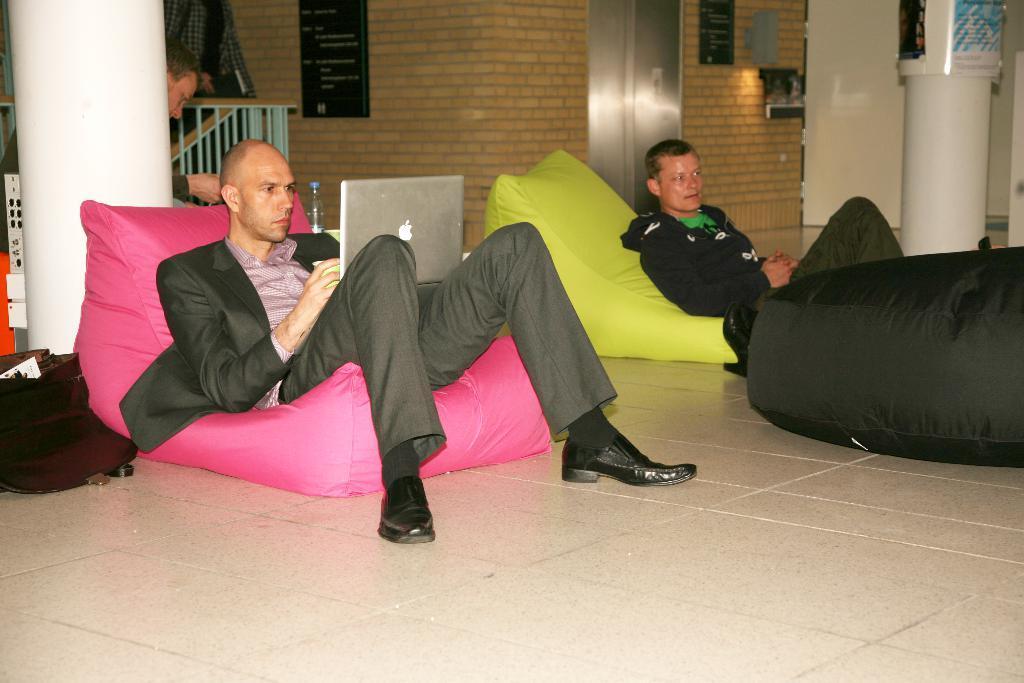Can you describe this image briefly? In the picture I can see bean bags, laptops, bottles and people. 